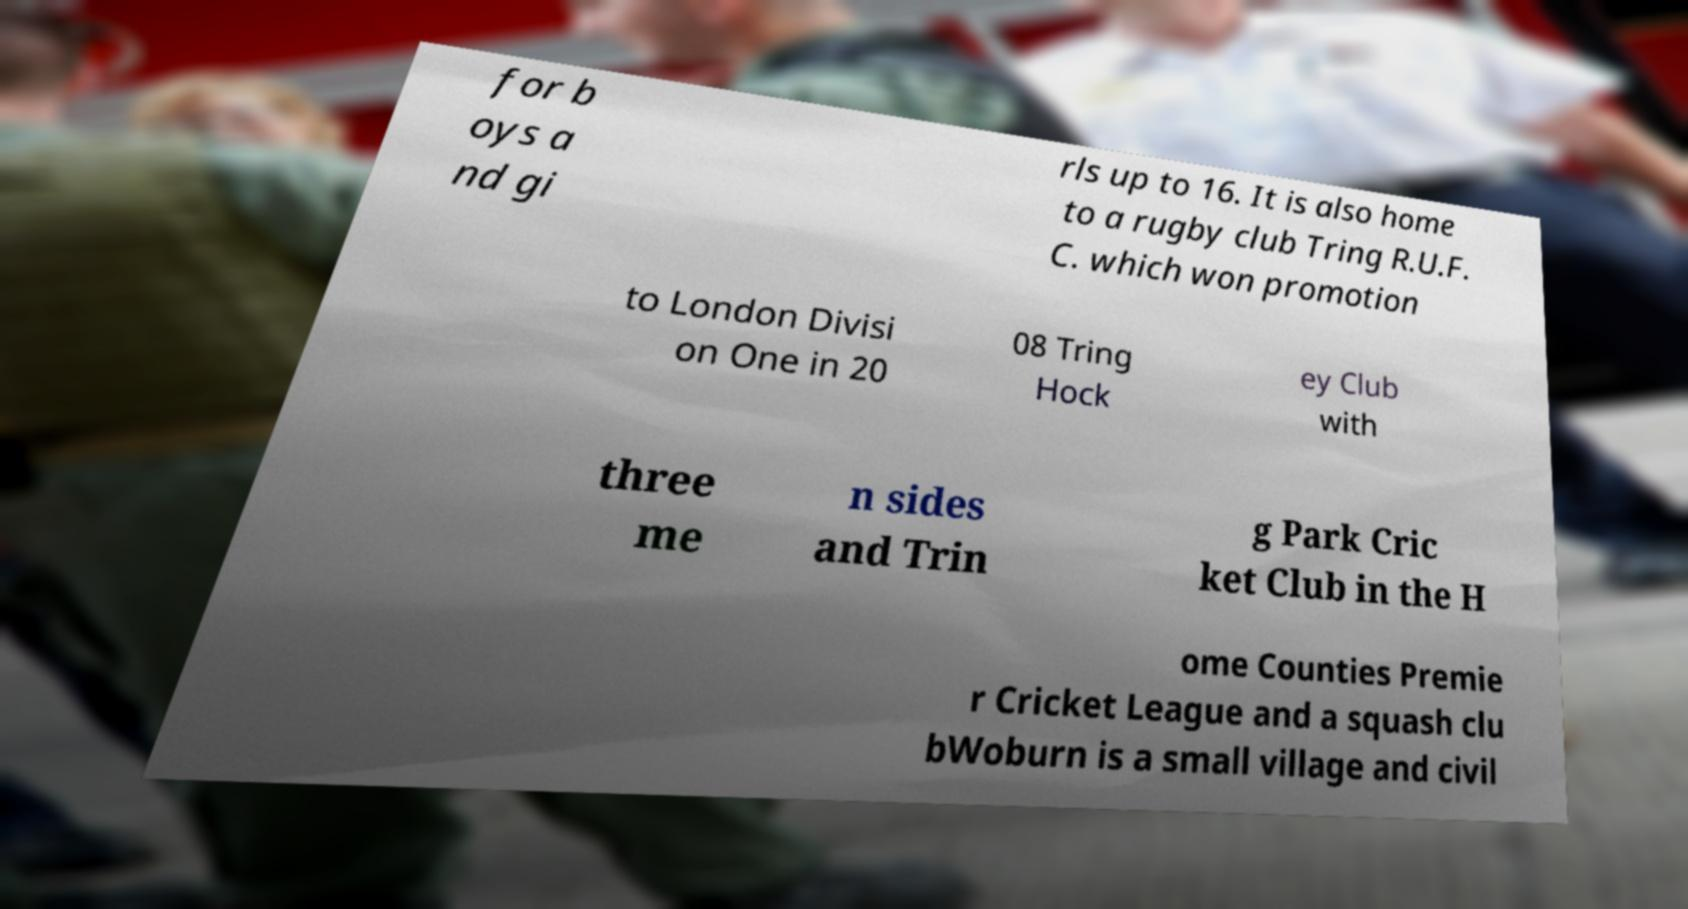There's text embedded in this image that I need extracted. Can you transcribe it verbatim? for b oys a nd gi rls up to 16. It is also home to a rugby club Tring R.U.F. C. which won promotion to London Divisi on One in 20 08 Tring Hock ey Club with three me n sides and Trin g Park Cric ket Club in the H ome Counties Premie r Cricket League and a squash clu bWoburn is a small village and civil 